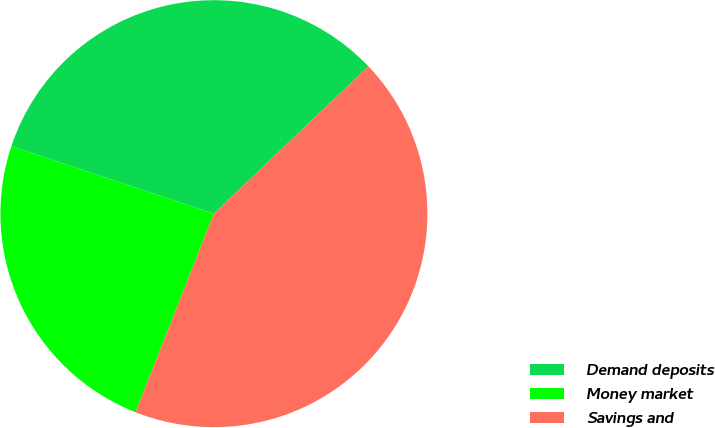Convert chart to OTSL. <chart><loc_0><loc_0><loc_500><loc_500><pie_chart><fcel>Demand deposits<fcel>Money market<fcel>Savings and<nl><fcel>32.76%<fcel>24.14%<fcel>43.1%<nl></chart> 